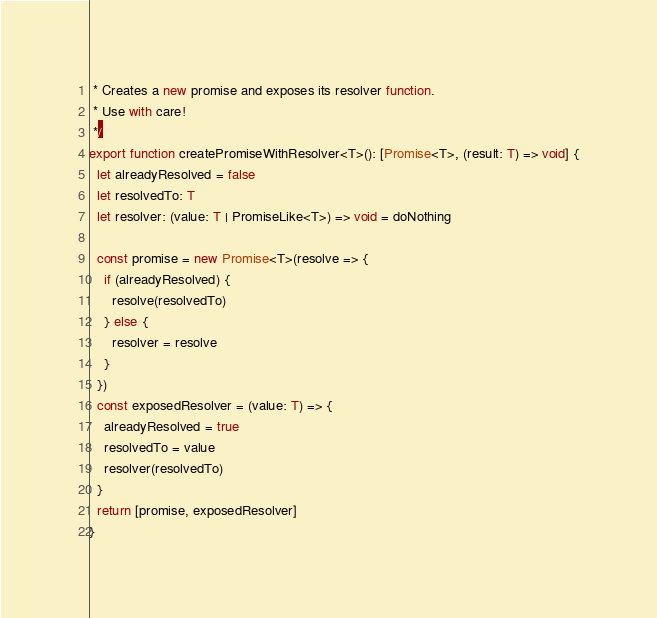Convert code to text. <code><loc_0><loc_0><loc_500><loc_500><_TypeScript_> * Creates a new promise and exposes its resolver function.
 * Use with care!
 */
export function createPromiseWithResolver<T>(): [Promise<T>, (result: T) => void] {
  let alreadyResolved = false
  let resolvedTo: T
  let resolver: (value: T | PromiseLike<T>) => void = doNothing

  const promise = new Promise<T>(resolve => {
    if (alreadyResolved) {
      resolve(resolvedTo)
    } else {
      resolver = resolve
    }
  })
  const exposedResolver = (value: T) => {
    alreadyResolved = true
    resolvedTo = value
    resolver(resolvedTo)
  }
  return [promise, exposedResolver]
}
</code> 